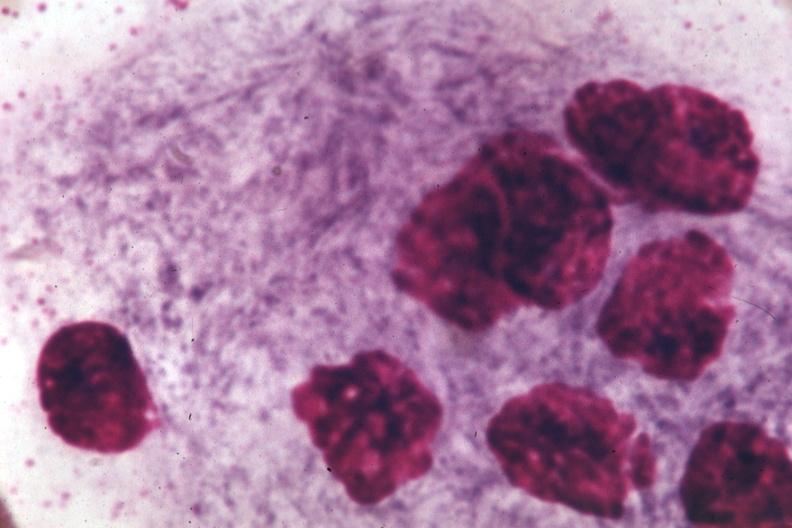s gaucher cell present?
Answer the question using a single word or phrase. Yes 